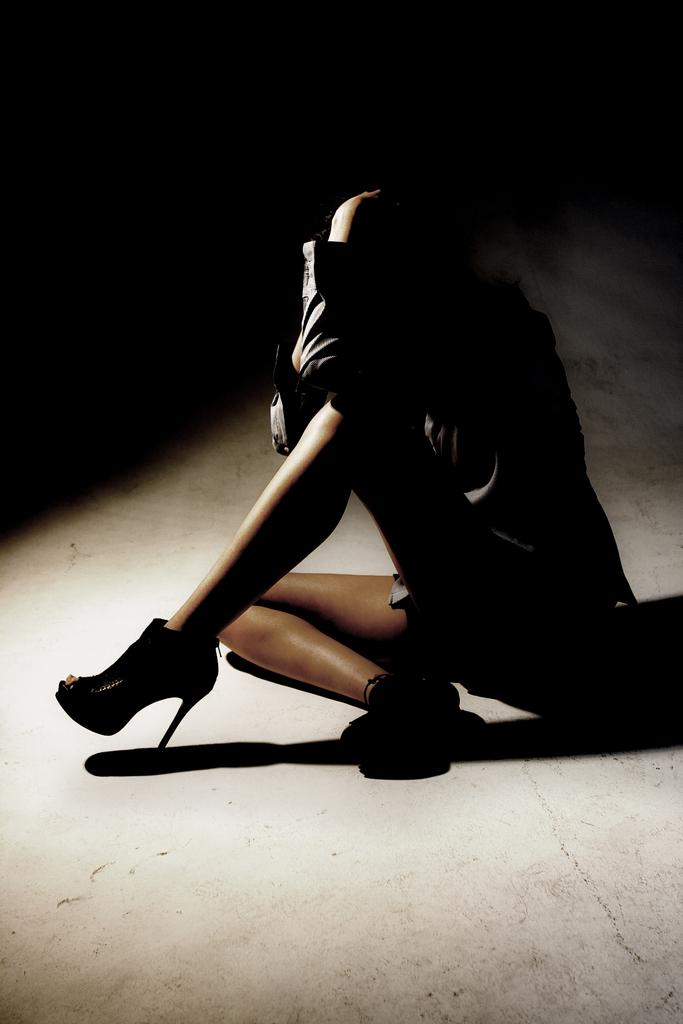What is the main subject of the image? There is a person in the image. What type of footwear is the person wearing? The person is wearing heels. What is the person's position in the image? The person is sitting on the ground. What can be observed about the background of the image? The background of the image is dark. How many drawers are visible in the image? There are no drawers present in the image. What type of island can be seen in the background of the image? There is no island visible in the image; the background is dark. 